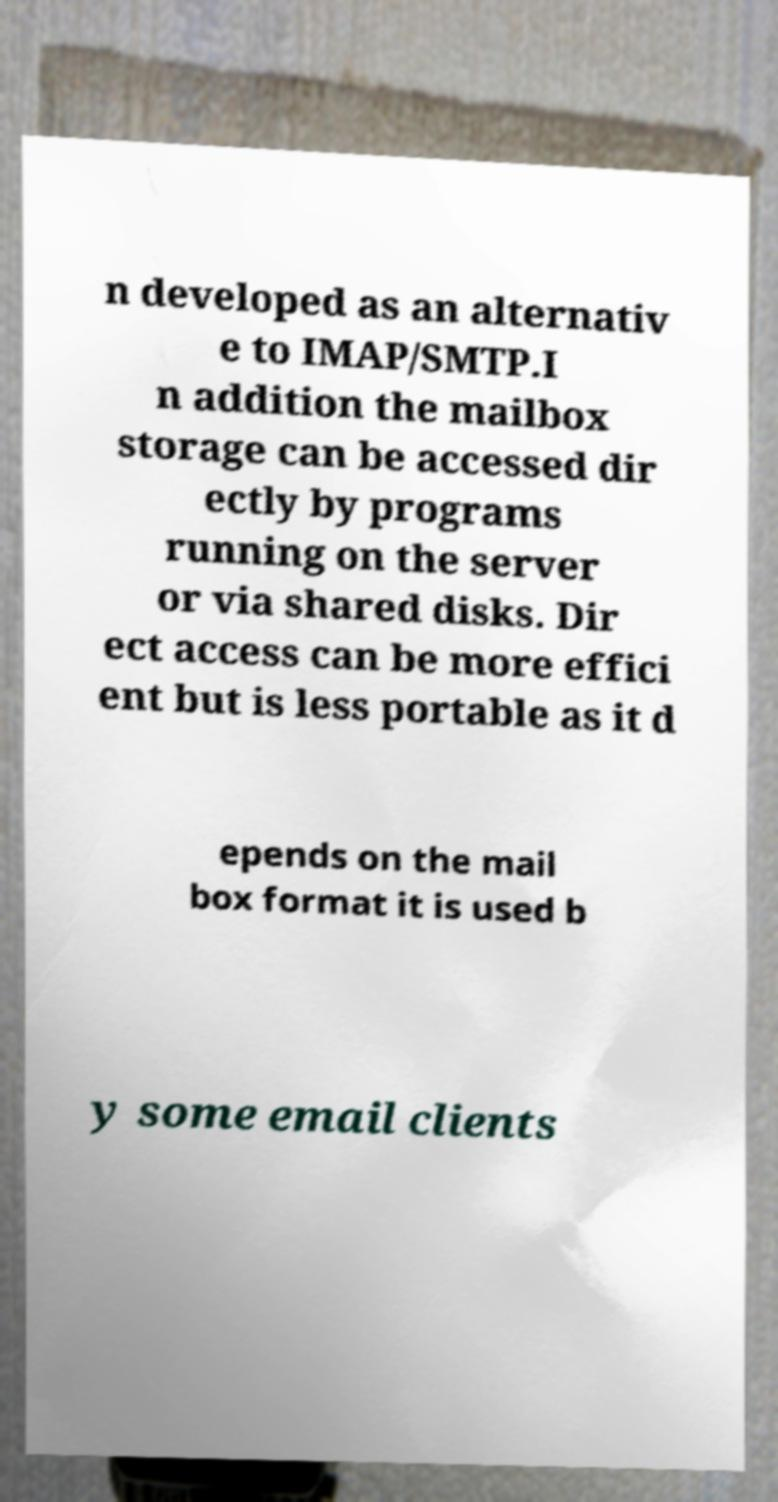There's text embedded in this image that I need extracted. Can you transcribe it verbatim? n developed as an alternativ e to IMAP/SMTP.I n addition the mailbox storage can be accessed dir ectly by programs running on the server or via shared disks. Dir ect access can be more effici ent but is less portable as it d epends on the mail box format it is used b y some email clients 